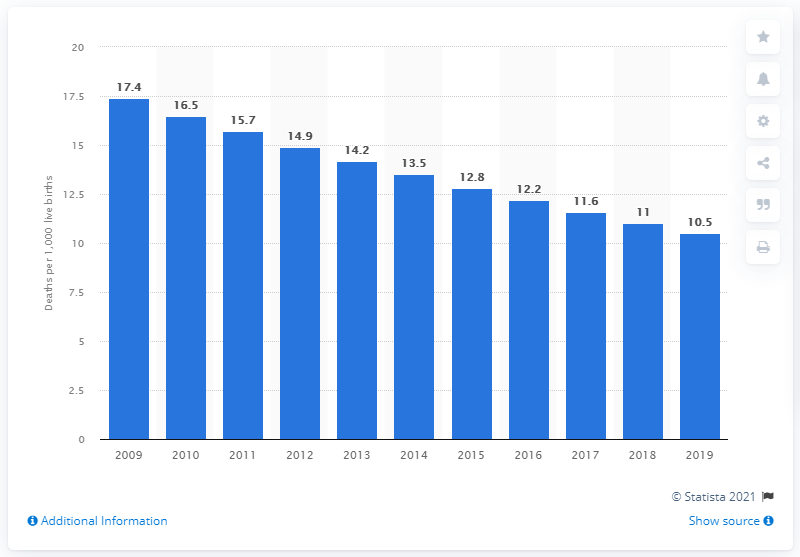Give some essential details in this illustration. The infant mortality rate in Armenia in 2019 was 10.5. 